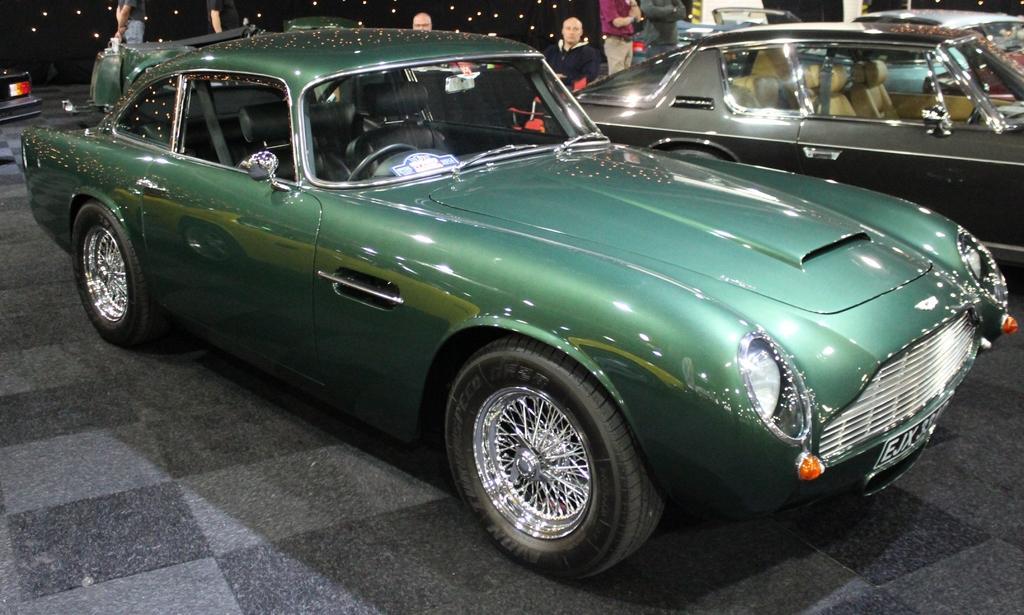Can you describe this image briefly? In this image we can group of vehicles parked on the ground, some persons are sitting on a chair and group of persons are standing on the floor. In the background, we can see some lights. 